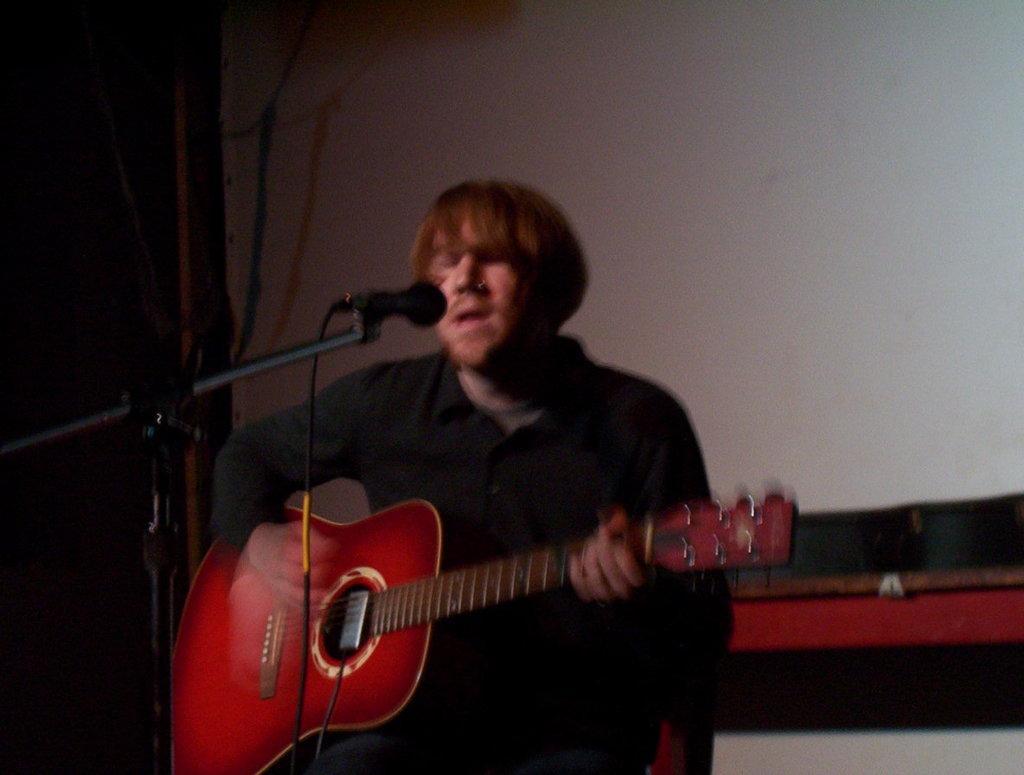In one or two sentences, can you explain what this image depicts? This is the man standing and singing a song. He is playing guitar. This is the mike with a mike stand. This is the wall which is white in color. 